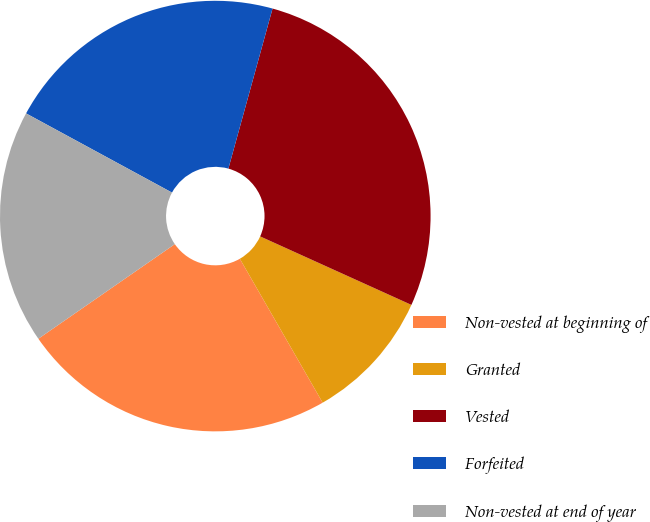<chart> <loc_0><loc_0><loc_500><loc_500><pie_chart><fcel>Non-vested at beginning of<fcel>Granted<fcel>Vested<fcel>Forfeited<fcel>Non-vested at end of year<nl><fcel>23.66%<fcel>9.92%<fcel>27.48%<fcel>21.37%<fcel>17.56%<nl></chart> 